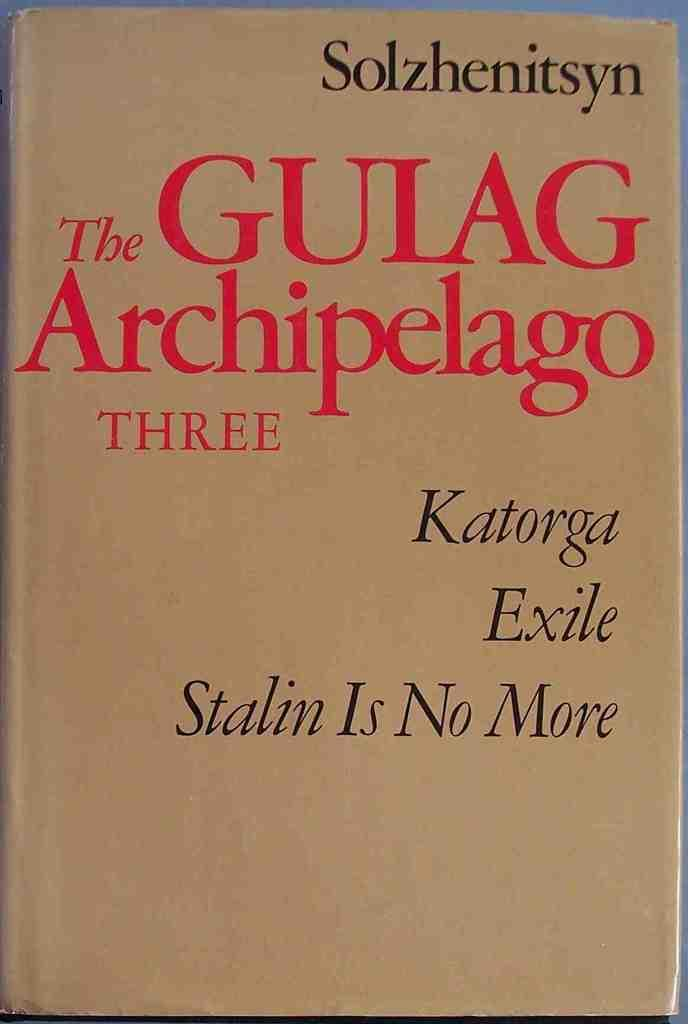<image>
Render a clear and concise summary of the photo. a copy of the book the gulag irchipelago three by Solzhenitsyn. 